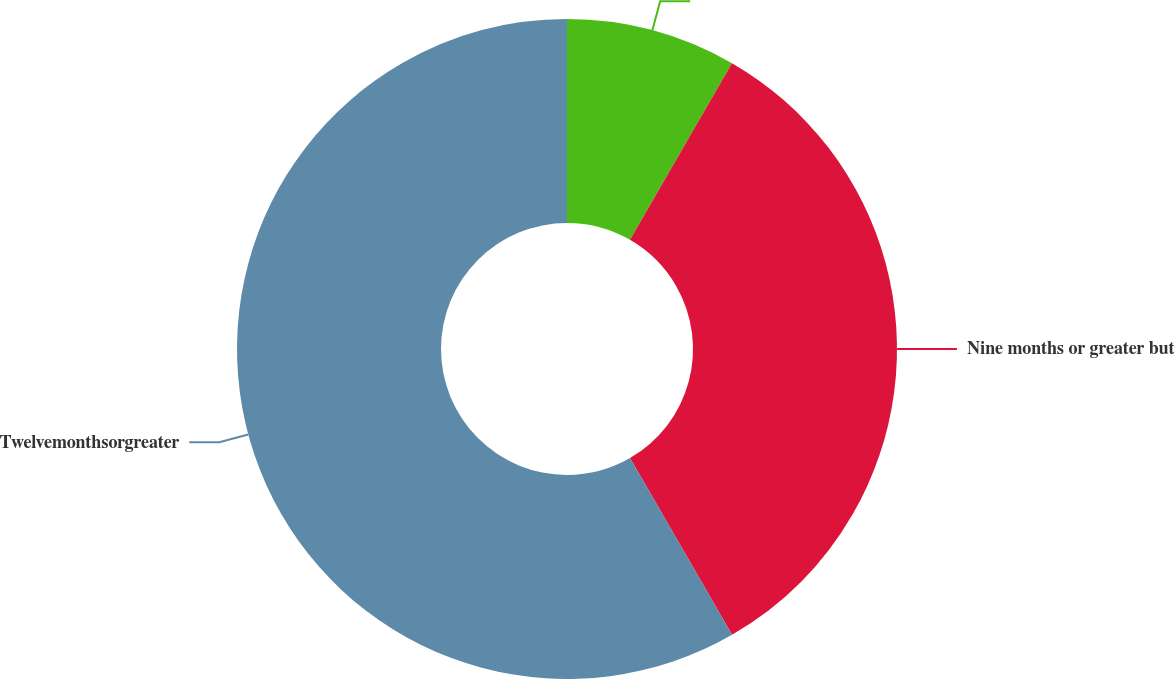<chart> <loc_0><loc_0><loc_500><loc_500><pie_chart><ecel><fcel>Nine months or greater but<fcel>Twelvemonthsorgreater<nl><fcel>8.33%<fcel>33.33%<fcel>58.33%<nl></chart> 